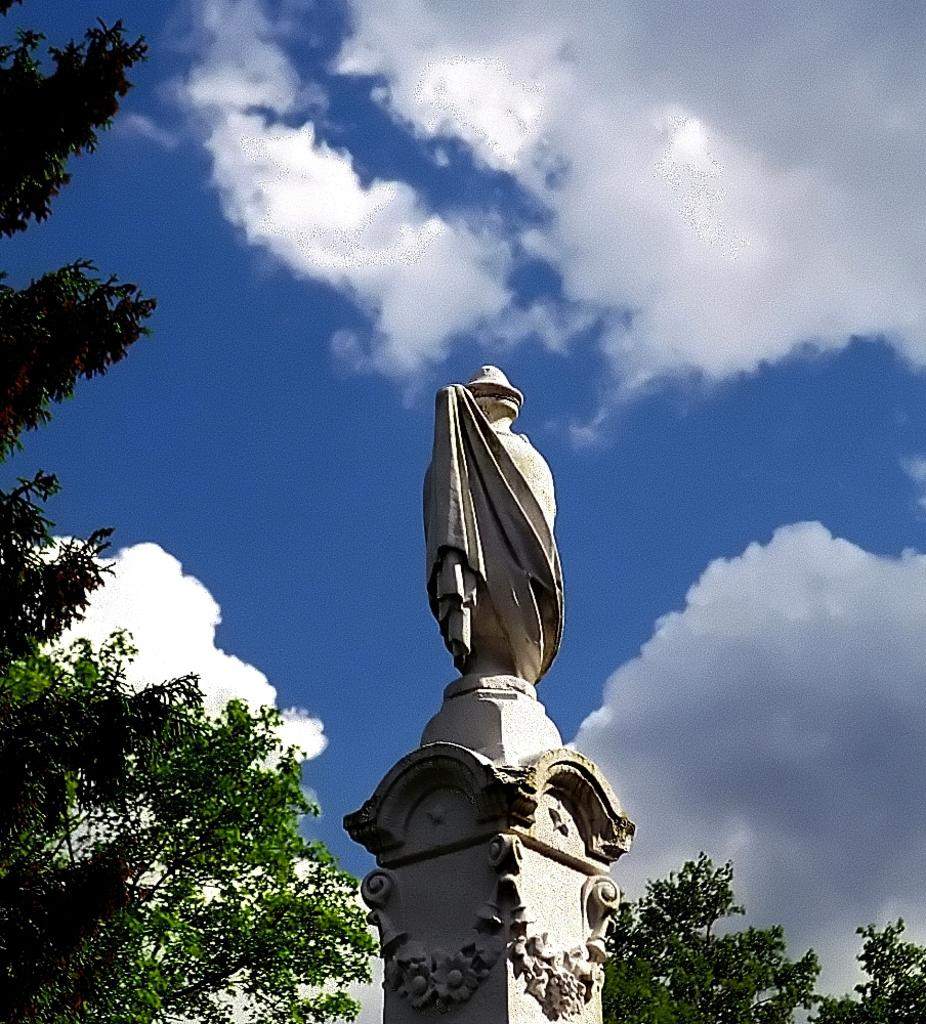What is located on top of the pillar in the image? There is a statue on a pillar in the image. What type of vegetation can be seen in the image? There are trees visible in the image. What is visible at the top of the image? The sky is visible at the top of the image. What can be seen in the sky in the image? Clouds are present in the sky. How many bulbs are attached to the statue in the image? There are no bulbs present in the image; the statue is on a pillar. What fact can be learned about the statue from the image? The image provides information about the statue's location (on a pillar) and its surroundings (trees, sky, and clouds), but it does not convey any specific facts about the statue itself. 